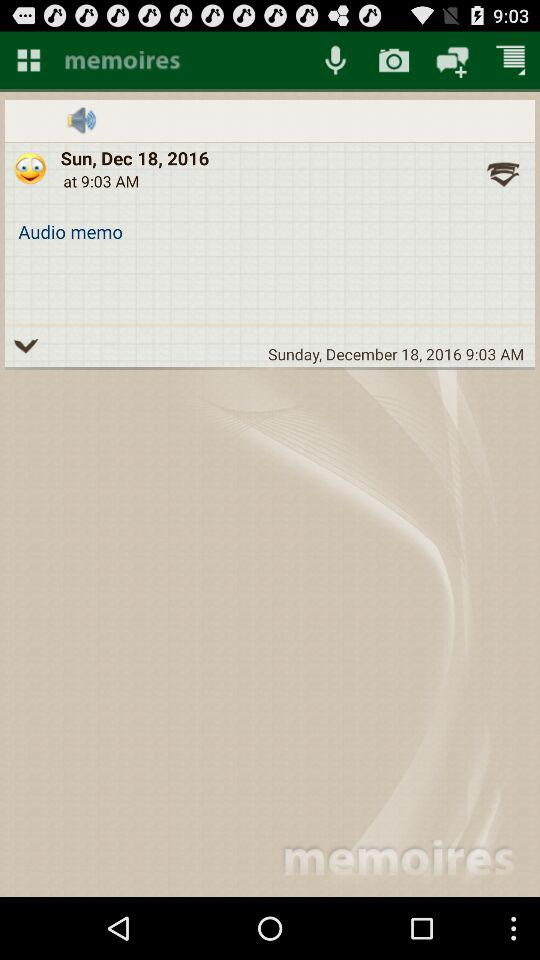What is the time given? The given time is 9:03 AM. 